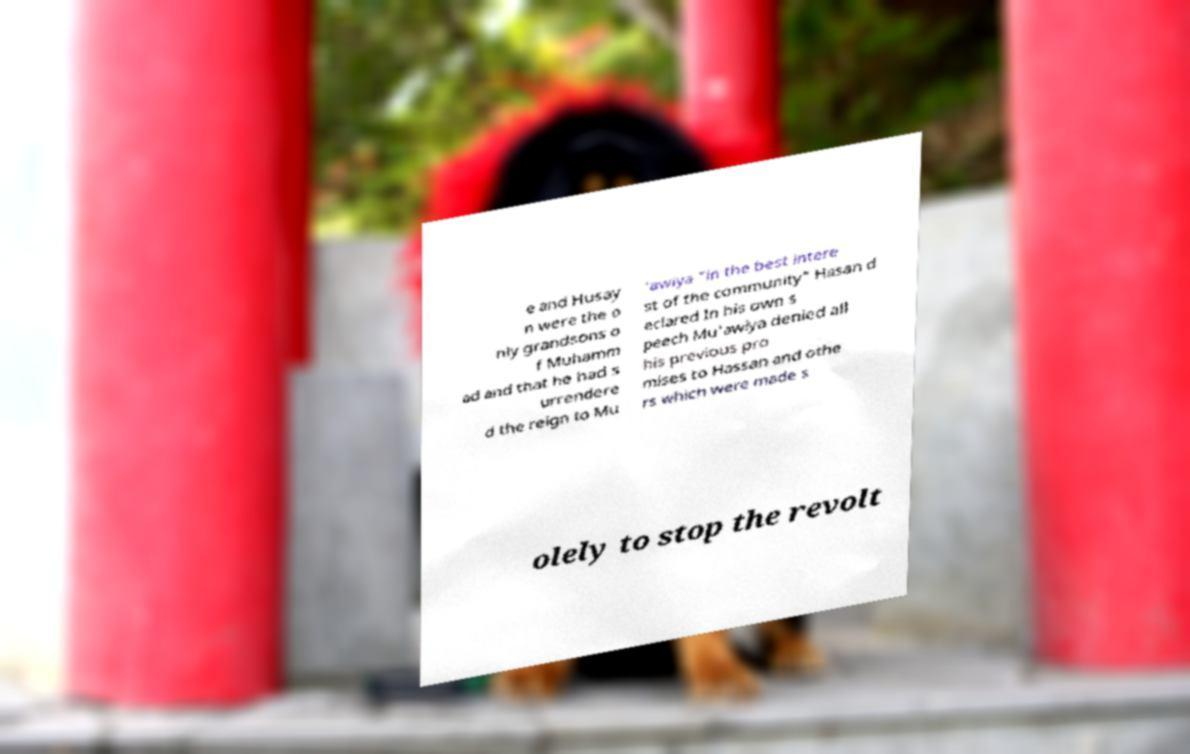There's text embedded in this image that I need extracted. Can you transcribe it verbatim? e and Husay n were the o nly grandsons o f Muhamm ad and that he had s urrendere d the reign to Mu 'awiya "in the best intere st of the community" Hasan d eclared In his own s peech Mu'awiya denied all his previous pro mises to Hassan and othe rs which were made s olely to stop the revolt 